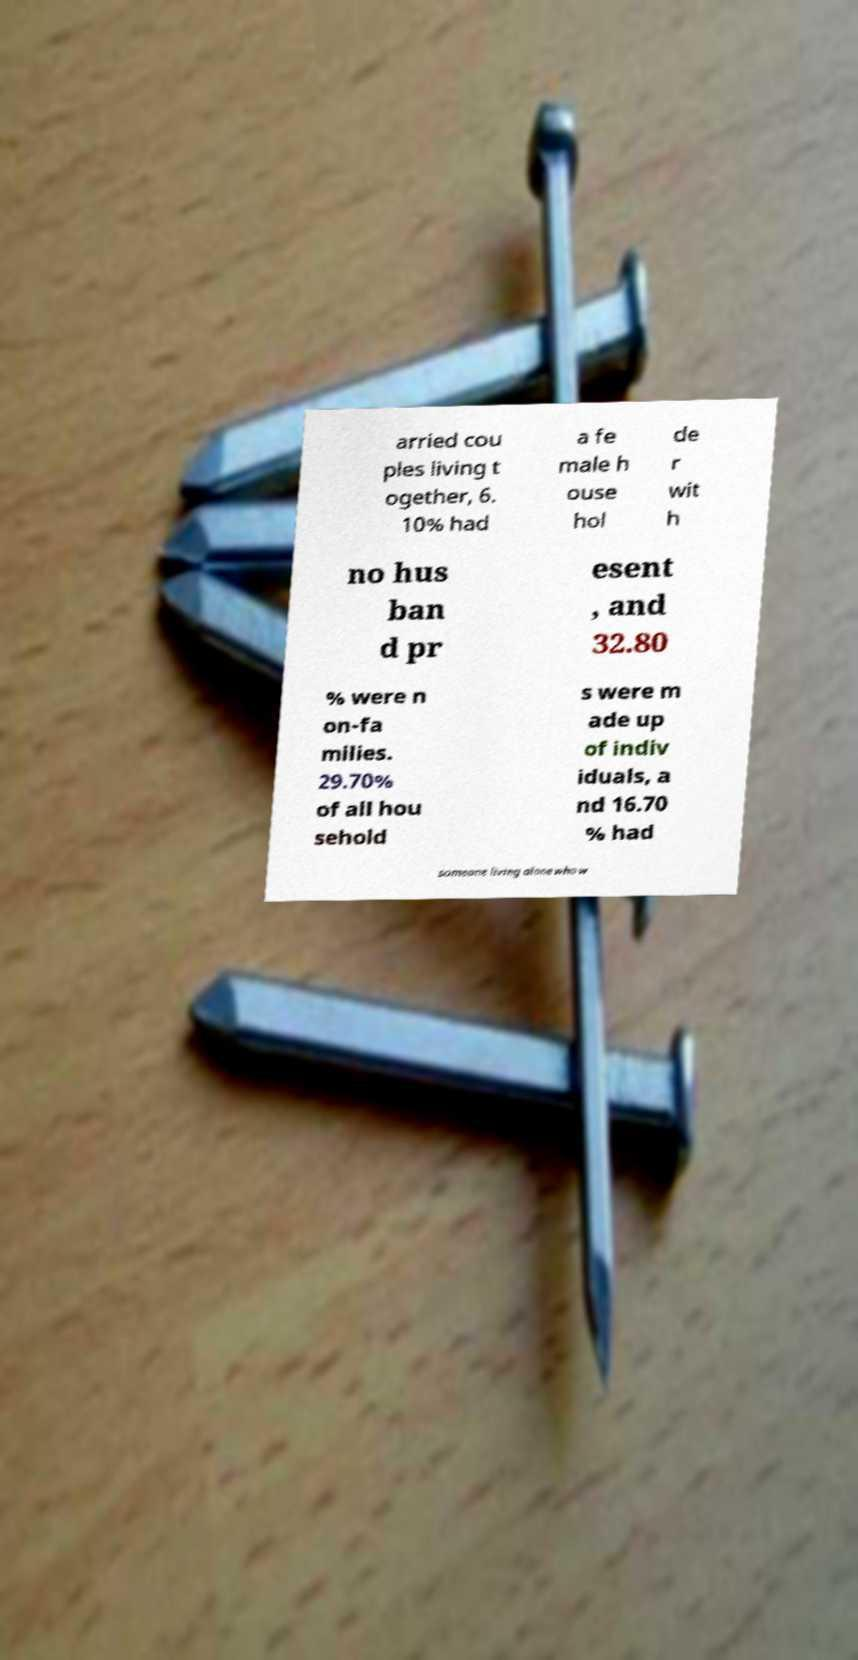Can you read and provide the text displayed in the image?This photo seems to have some interesting text. Can you extract and type it out for me? arried cou ples living t ogether, 6. 10% had a fe male h ouse hol de r wit h no hus ban d pr esent , and 32.80 % were n on-fa milies. 29.70% of all hou sehold s were m ade up of indiv iduals, a nd 16.70 % had someone living alone who w 